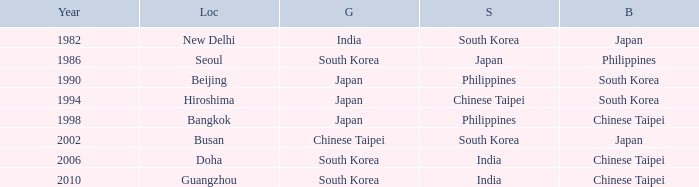Which Bronze has a Year smaller than 1994, and a Silver of south korea? Japan. 